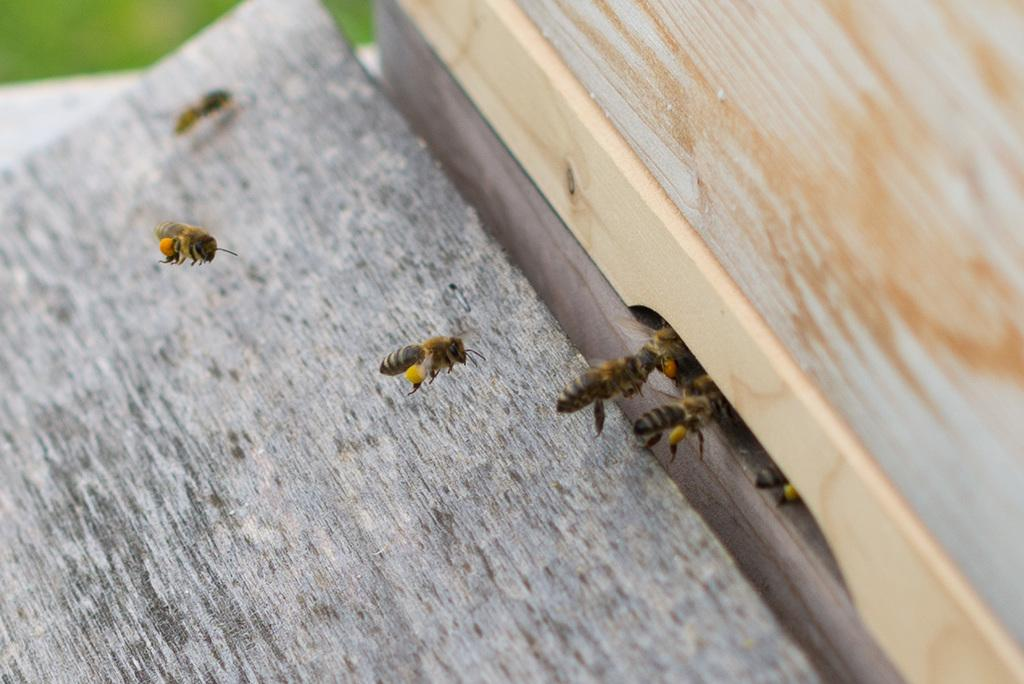What is the main object in the image? There is a wooden plank in the image. What is unique about the wooden plank? The wooden plank has holes in it. What is happening with the bees in the image? Bees are flying and going into the holes in the wooden plank. What type of religion is being practiced in the image? There is no indication of any religious practice in the image; it features a wooden plank with holes and bees going into them. 